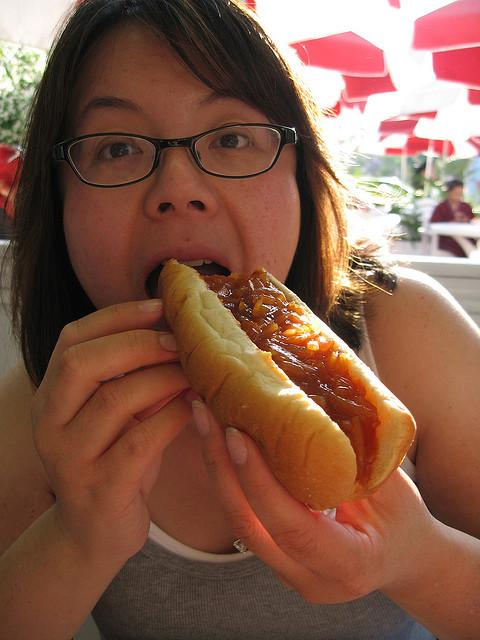What food is that bun normally used for? Please explain your reasoning. hot dogs. She is eating some kind of cased sausage. 